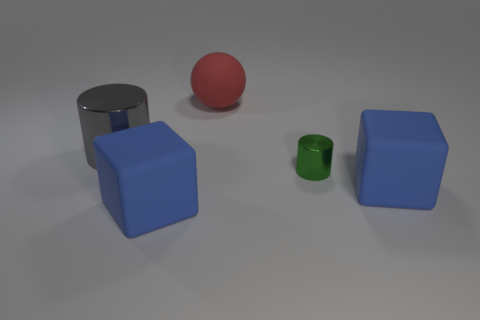Could you guess what material the green object is made of based on its appearance? While it's difficult to determine the exact material from appearance alone, the green object looks like it has a smooth, possibly painted surface, which might indicate a material like painted wood or smooth plastic. 